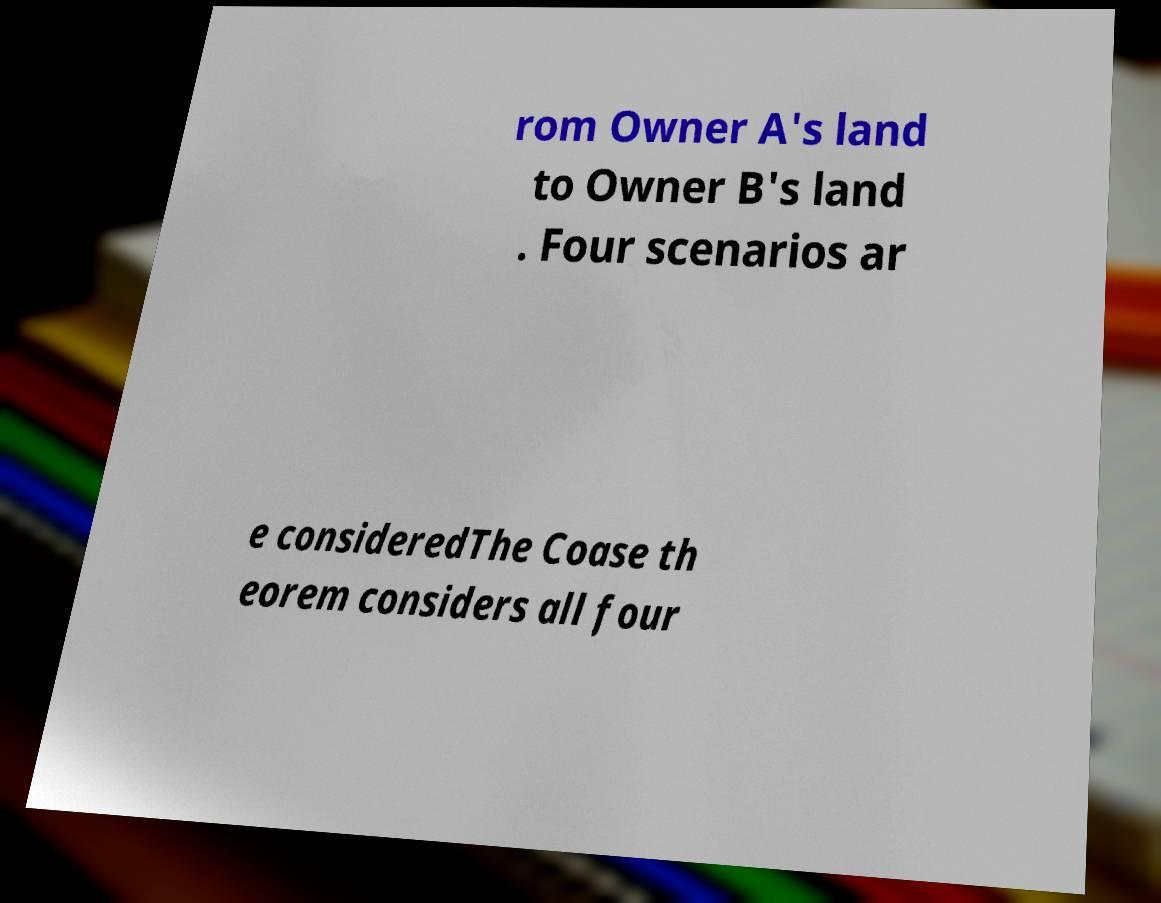What messages or text are displayed in this image? I need them in a readable, typed format. rom Owner A's land to Owner B's land . Four scenarios ar e consideredThe Coase th eorem considers all four 